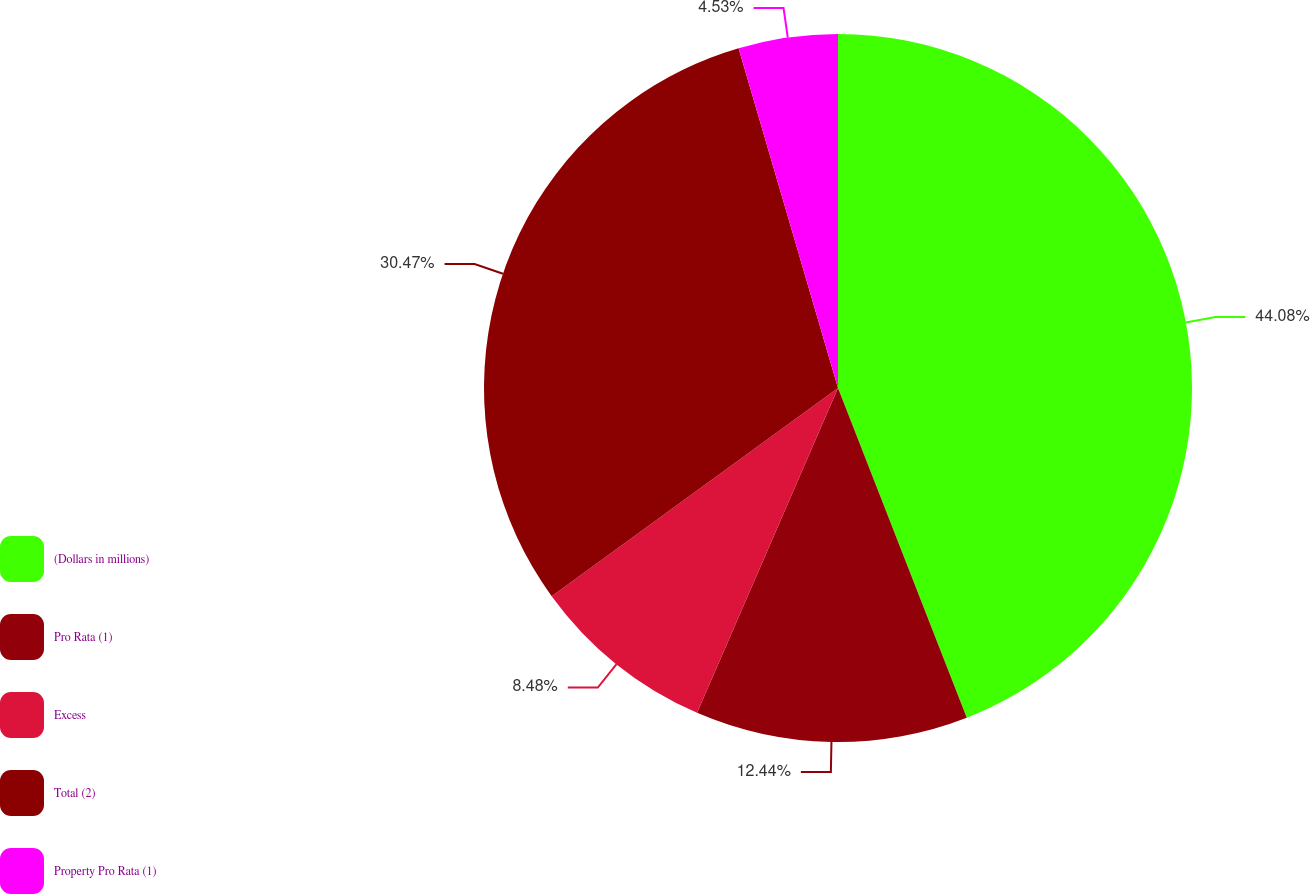Convert chart to OTSL. <chart><loc_0><loc_0><loc_500><loc_500><pie_chart><fcel>(Dollars in millions)<fcel>Pro Rata (1)<fcel>Excess<fcel>Total (2)<fcel>Property Pro Rata (1)<nl><fcel>44.07%<fcel>12.44%<fcel>8.48%<fcel>30.47%<fcel>4.53%<nl></chart> 